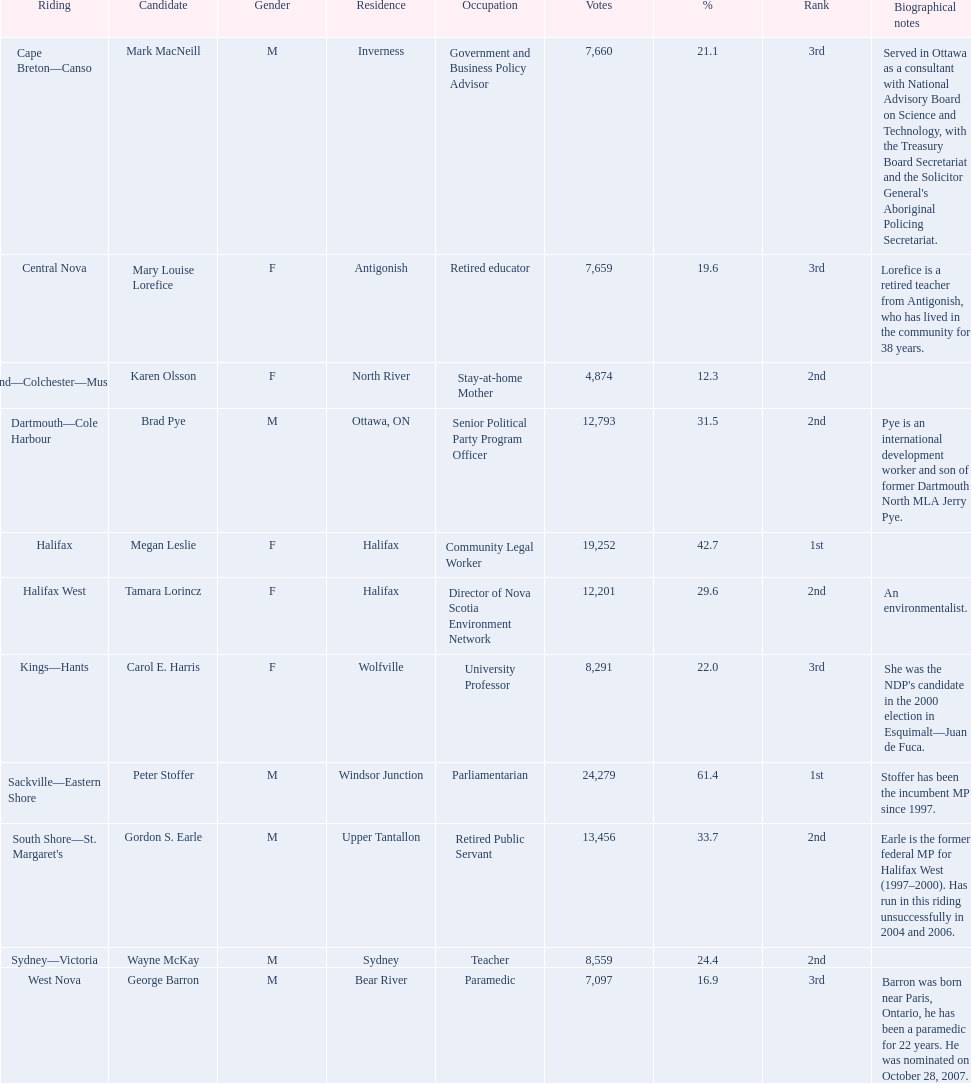Who are all the nominees? Mark MacNeill, Mary Louise Lorefice, Karen Olsson, Brad Pye, Megan Leslie, Tamara Lorincz, Carol E. Harris, Peter Stoffer, Gordon S. Earle, Wayne McKay, George Barron. How many votes did they get? 7,660, 7,659, 4,874, 12,793, 19,252, 12,201, 8,291, 24,279, 13,456, 8,559, 7,097. And of those, how many were in favor of megan leslie? 19,252. 